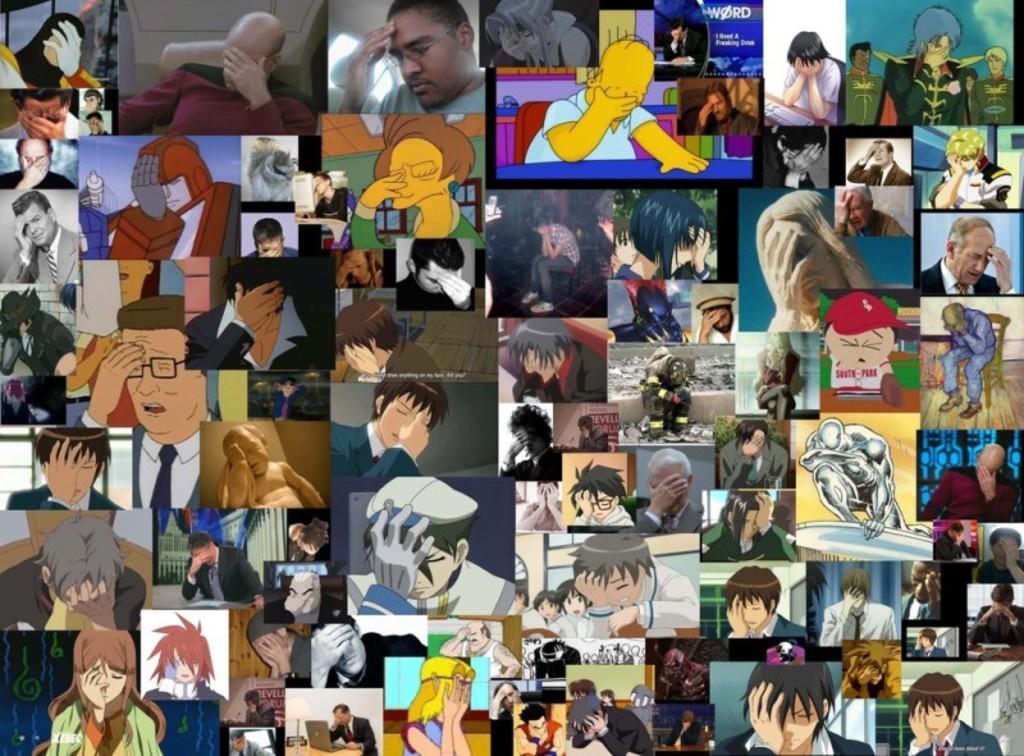Please provide a concise description of this image. This is an edited image with the collage of images and we can see the group of persons in the image and we can see the text, sky and many other objects. 